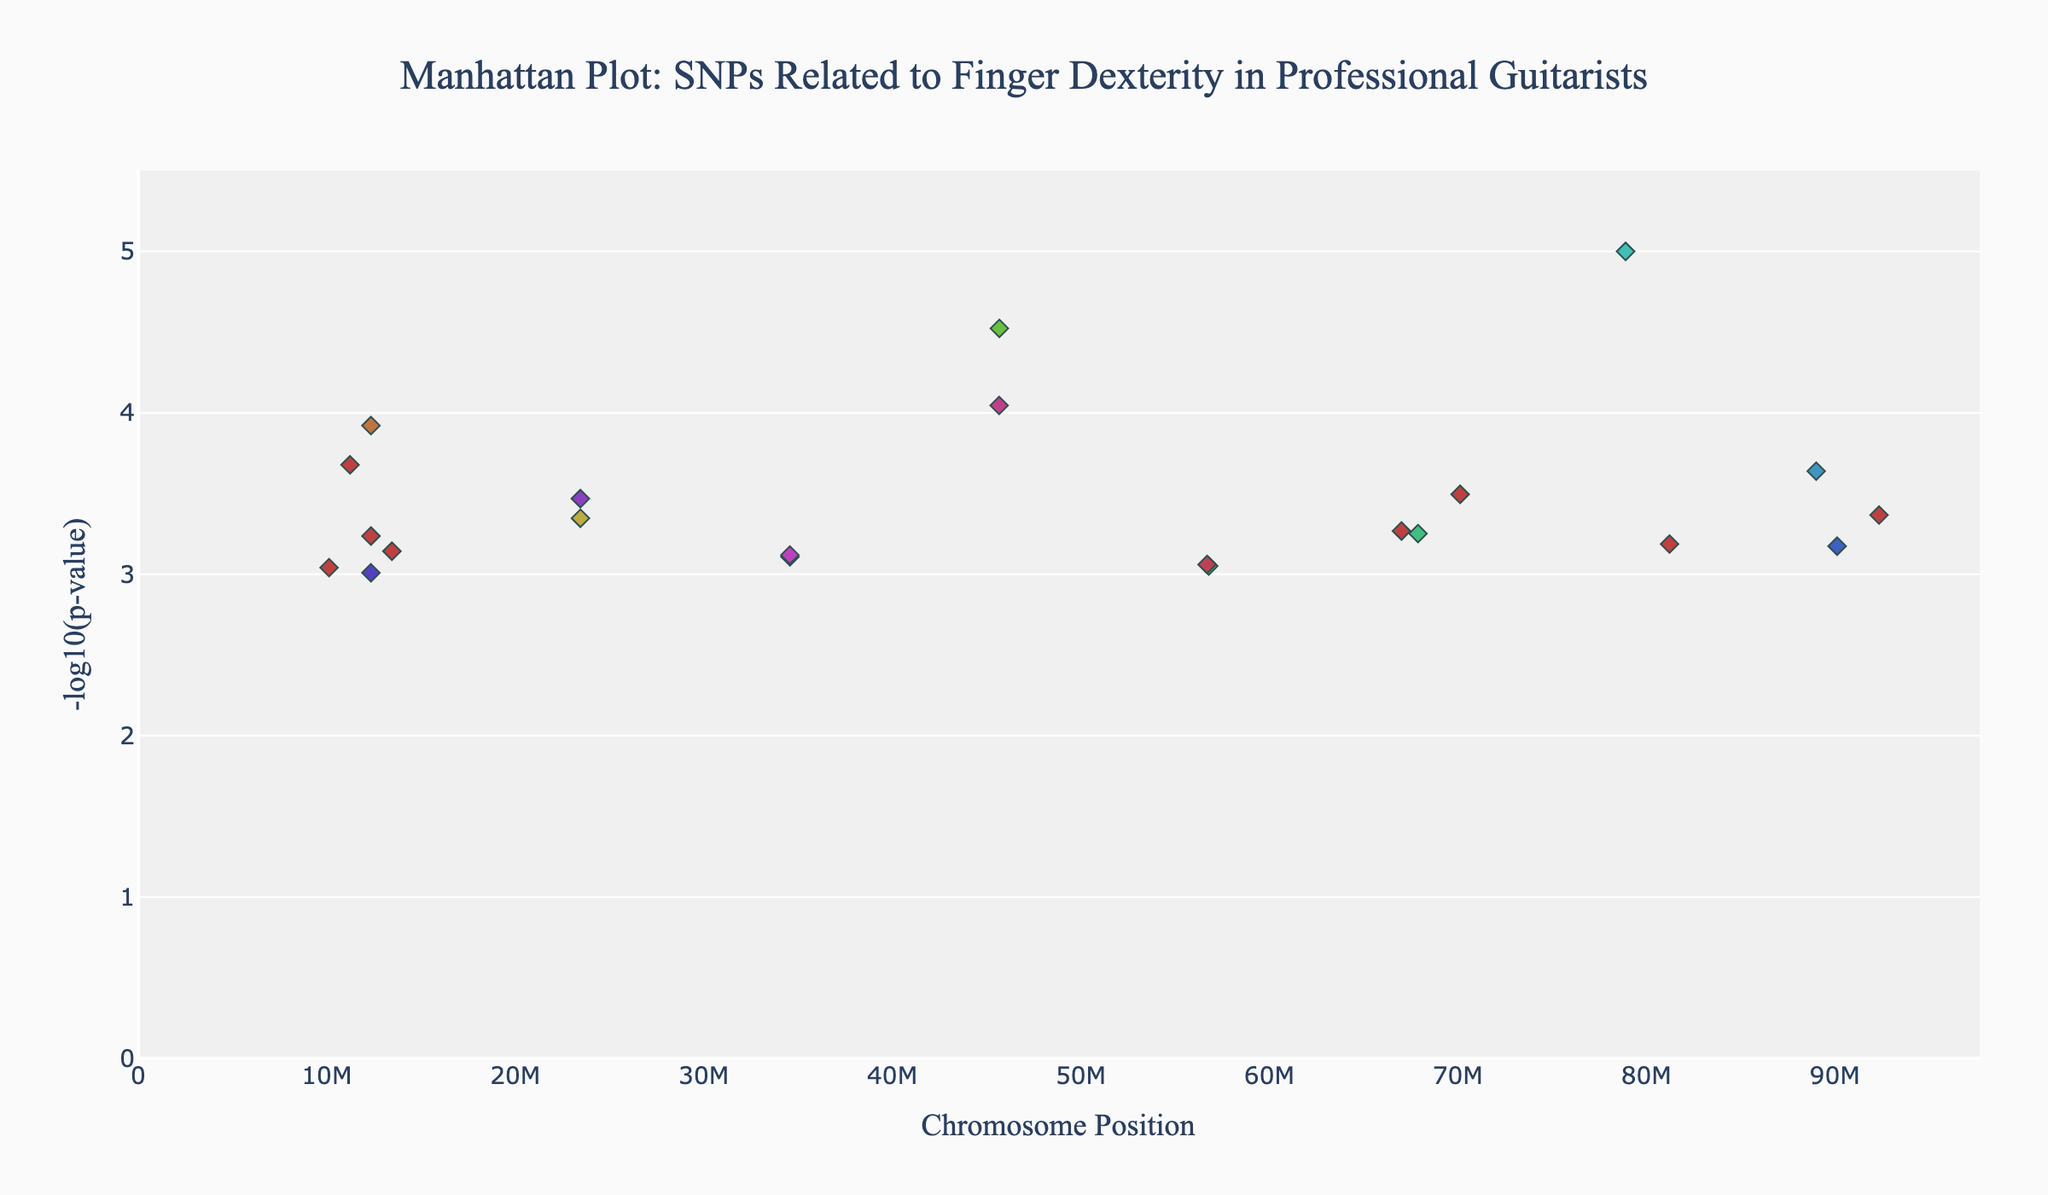Which chromosome has the SNP with the lowest p-value? The lowest p-value corresponds to the highest y-value (neg_log_p) in the plot. By observing the colors and positions, we find that the highest peak is on chromosome 7.
Answer: Chromosome 7 How many chromosomes have at least one SNP with a p-value less than 0.0001? SNPs with p-values less than 0.0001 will have y-values (neg_log_p) greater than 4. By observing the peaks above this threshold, the chromosomes are 1, 4, 7, 13, and 20.
Answer: 5 chromosomes What is the range of -log10(p-value) observed in the plot? On the y-axis, the values range from the smallest -log10(p-value) to the largest. The plot shows values from around 3 to just under 6 for the highest peak.
Answer: ~3 to ~5.9 Which chromosome has the smallest number of SNPs depicted in this plot? The chromosome with the fewest points (SNPs) on the x-axis will be the one with the smallest number of SNPs. Observing the distribution, chromosomes 14 and 19 seem to have the least, both with one SNP each.
Answer: Chromosome 14 or 19 (either one) What range of positions in chromosome 4 contains the SNPs in the plot? By focusing on chromosome 4 and reading the positions on the x-axis where its points (SNPs) are plotted, we see a single point at position 45678901.
Answer: 45678901 Are there any chromosomes that do not meet genome-wide significance (p < 5e-8)? Genome-wide significance corresponds to a dash red line threshold on the y-axis. Any chromosome with all points (SNPs) below the red line does not meet the threshold. Chromosomes other than 4, 7, and perhaps another, do not cross this line.
Answer: All except Chromosome 4 and 7 Which chromosomes have SNPs with a higher -log10(p-value) than Chromosome 13? Look at the plot to see the peak of Chromosome 13 and then compare with others. Chromosome 4 and 7 have higher peaks.
Answer: Chromosome 4 and 7 Which SNP has the second lowest p-value? The second lowest p-value corresponds to the second highest y-value (neg_log_p) peak. The peak with the second highest y-value is on chromosome 4, and the SNP is rs6687859.
Answer: rs6687859 